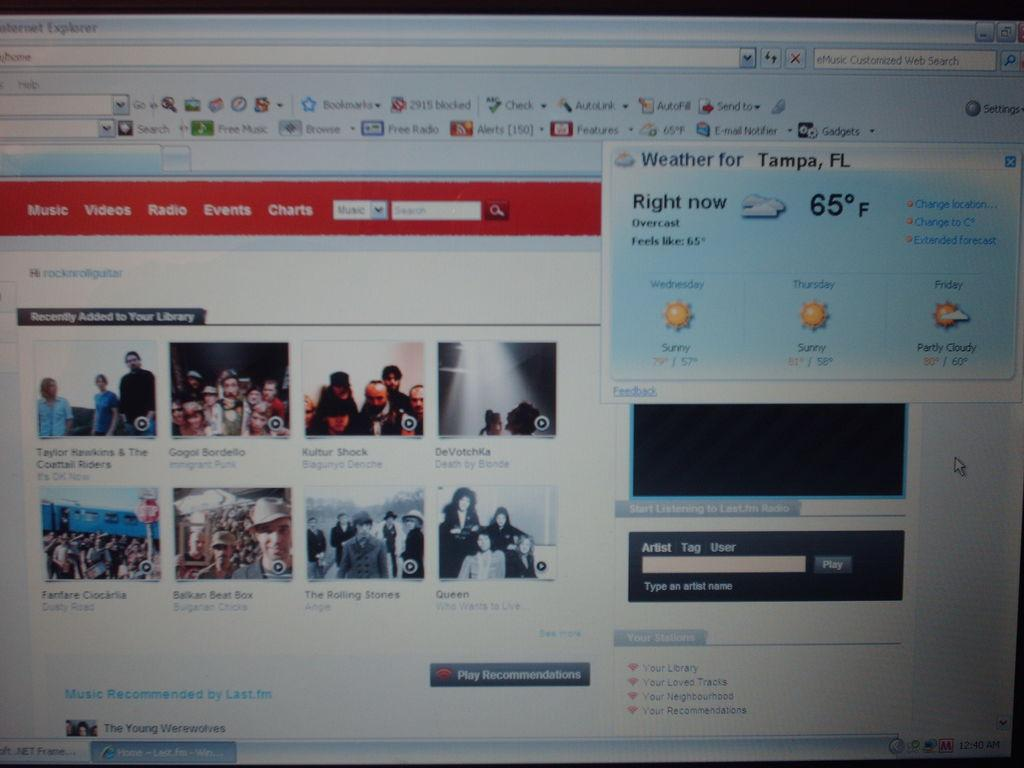<image>
Share a concise interpretation of the image provided. A computer monitor on a website that shows the weather at partly cloudy and 65 degrees. 